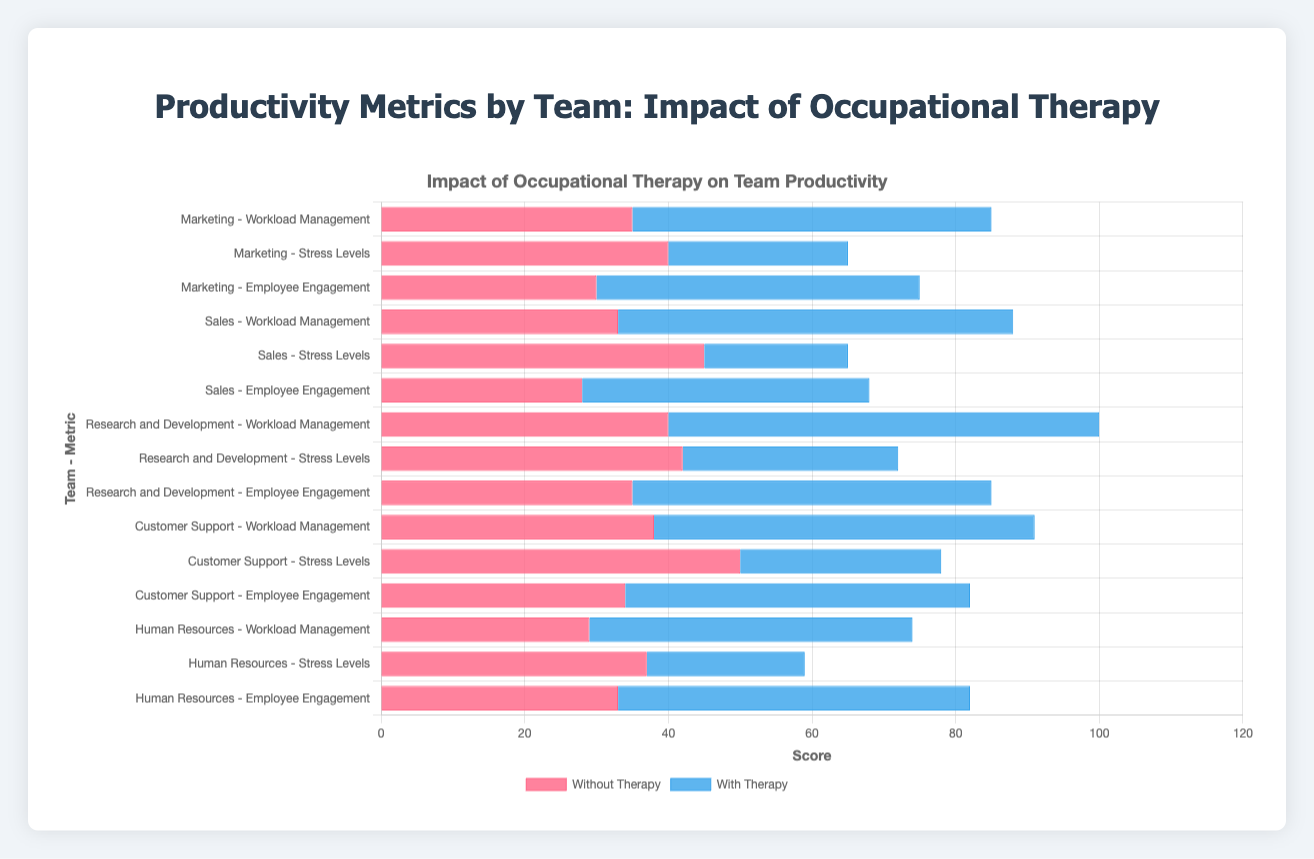What is the difference in Workload Management scores between the Marketing and Sales teams without therapy? The Workload Management score for the Marketing team without therapy is 35, while for the Sales team, it is 33. The difference is 35 - 33 = 2.
Answer: 2 Which team has the lowest Stress Levels with therapy? By examining the Stress Levels with therapy for each team, the values are: Marketing (25), Sales (20), Research and Development (30), Customer Support (28), and Human Resources (22). The lowest value is 20, which is for the Sales team.
Answer: Sales Which team experiences the greatest improvement in Employee Engagement scores with therapy? Improvement is calculated by the difference between the scores with and without therapy. The differences are: 15 for Marketing (45 - 30), 12 for Sales (40 - 28), 15 for Research and Development (50 - 35), 14 for Customer Support (48 - 34), and 16 for Human Resources (49 - 33). The greatest improvement is 16, which is for Human Resources.
Answer: Human Resources What is the average Employee Engagement score for the teams without therapy? The Employee Engagement scores without therapy are: Marketing (30), Sales (28), Research and Development (35), Customer Support (34), and Human Resources (33). The average score is (30 + 28 + 35 + 34 + 33) / 5 = 32.
Answer: 32 Which metric shows the most significant reduction in stress levels when comparing without and with therapy across all teams? To determine the most significant reduction, we calculate the reduction for each team: Marketing (40 - 25 = 15), Sales (45 - 20 = 25), Research and Development (42 - 30 = 12), Customer Support (50 - 28 = 22), and Human Resources (37 - 22 = 15). The most significant reduction is 25 for the Sales team.
Answer: Stress Levels for Sales What is the overall impact on Workload Management metrics with therapy across all teams (sum of scores)? The Workload Management scores with therapy across the teams are: Marketing (50), Sales (55), Research and Development (60), Customer Support (53), and Human Resources (45). The total impact is 50 + 55 + 60 + 53 + 45 = 263.
Answer: 263 Which two teams have the smallest difference in Employee Engagement scores with therapy? The Employee Engagement scores with therapy are: Marketing (45), Sales (40), Research and Development (50), Customer Support (48), and Human Resources (49). The closest differences are between Customer Support and Human Resources (48 - 49) = 1.
Answer: Customer Support and Human Resources 